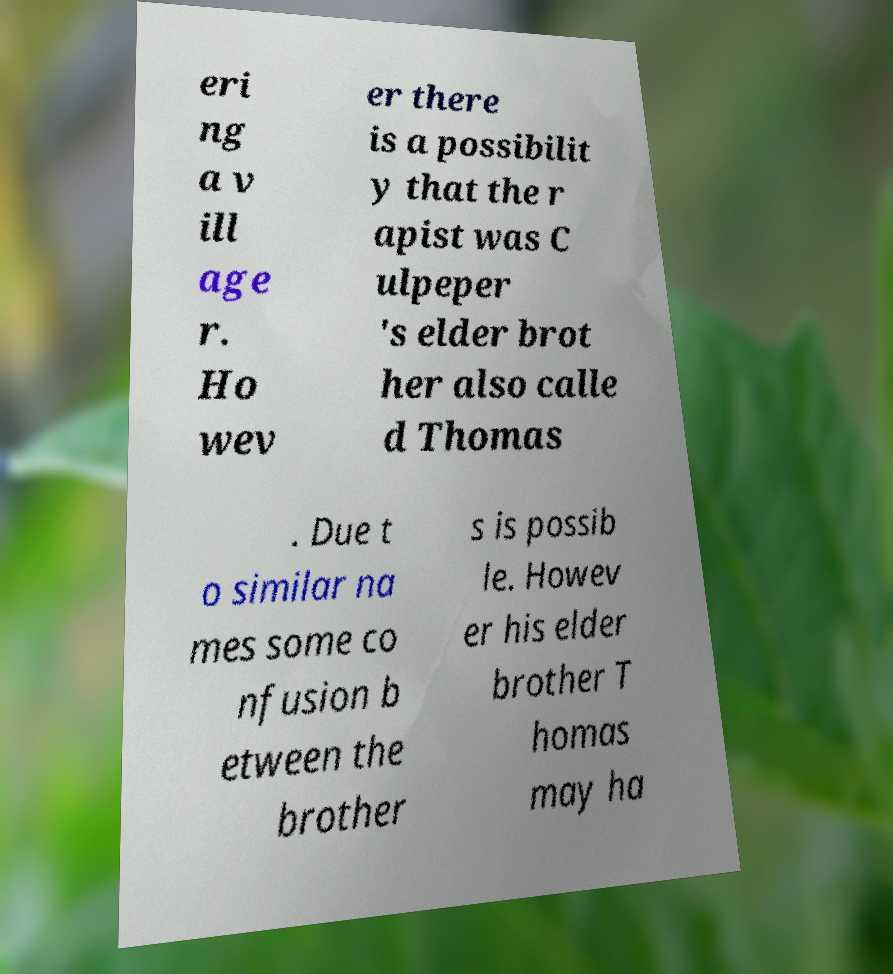There's text embedded in this image that I need extracted. Can you transcribe it verbatim? eri ng a v ill age r. Ho wev er there is a possibilit y that the r apist was C ulpeper 's elder brot her also calle d Thomas . Due t o similar na mes some co nfusion b etween the brother s is possib le. Howev er his elder brother T homas may ha 